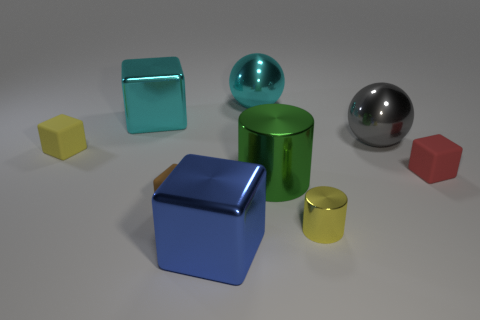Subtract all red blocks. How many blocks are left? 4 Subtract all large cyan metal cubes. How many cubes are left? 4 Subtract all red blocks. Subtract all brown spheres. How many blocks are left? 4 Add 1 shiny balls. How many objects exist? 10 Subtract all spheres. How many objects are left? 7 Subtract 0 gray cylinders. How many objects are left? 9 Subtract all big red spheres. Subtract all large blue blocks. How many objects are left? 8 Add 6 small blocks. How many small blocks are left? 9 Add 5 small green metal spheres. How many small green metal spheres exist? 5 